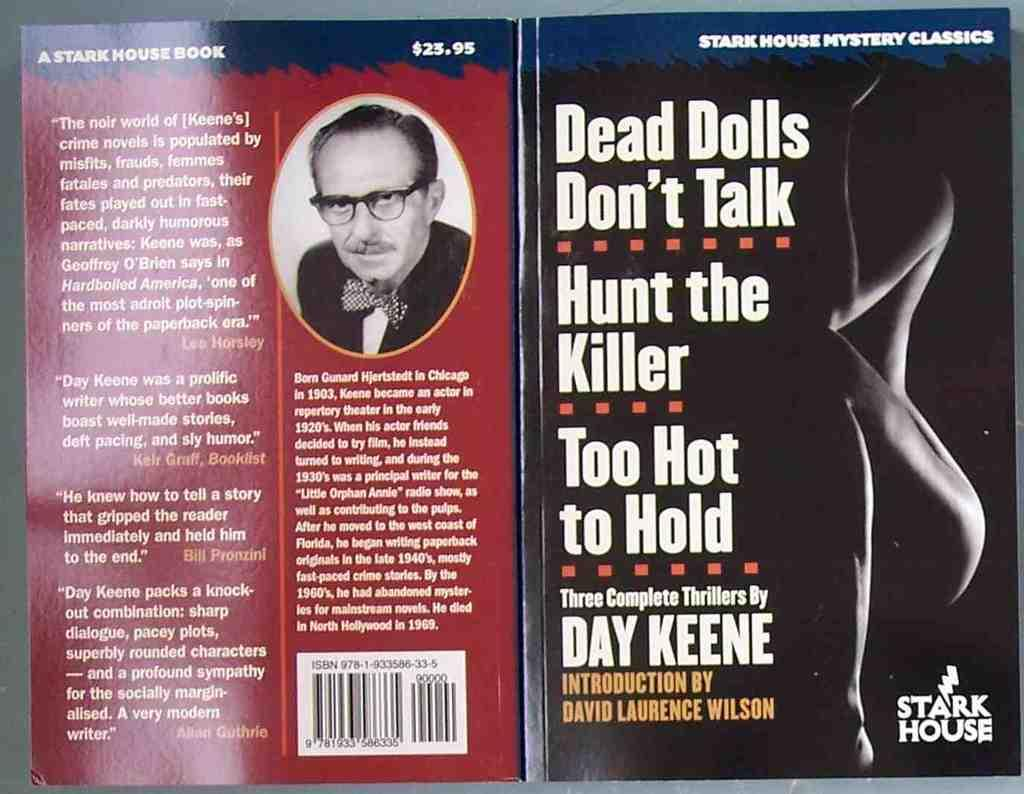<image>
Give a short and clear explanation of the subsequent image. Dead Dolls Dont Talk by Day Keene was published by Stark House 